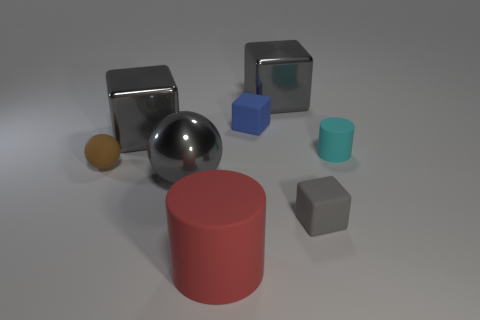There is a big object that is made of the same material as the brown ball; what is its color?
Keep it short and to the point. Red. Is the number of tiny gray matte cubes behind the small cyan cylinder greater than the number of small blue rubber objects in front of the tiny blue rubber block?
Your answer should be very brief. No. How many other things are the same size as the red rubber thing?
Your answer should be very brief. 3. There is a thing that is both to the right of the brown rubber object and on the left side of the metal sphere; what material is it?
Offer a terse response. Metal. There is another thing that is the same shape as the big red thing; what is its material?
Make the answer very short. Rubber. There is a small matte block that is behind the cube that is in front of the tiny matte ball; what number of big gray blocks are to the left of it?
Provide a succinct answer. 1. Are there any other things that have the same color as the small cylinder?
Give a very brief answer. No. What number of rubber things are to the right of the tiny blue thing and left of the small cyan cylinder?
Your response must be concise. 1. There is a gray block that is on the left side of the big cylinder; does it have the same size as the cylinder behind the large rubber object?
Provide a succinct answer. No. How many things are either large gray objects on the left side of the red object or matte things?
Give a very brief answer. 7. 